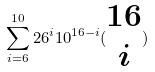<formula> <loc_0><loc_0><loc_500><loc_500>\sum _ { i = 6 } ^ { 1 0 } 2 6 ^ { i } 1 0 ^ { 1 6 - i } ( \begin{matrix} 1 6 \\ i \end{matrix} )</formula> 